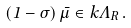<formula> <loc_0><loc_0><loc_500><loc_500>( { 1 } - \sigma ) \, \bar { \mu } \in k \Lambda _ { R } \, .</formula> 